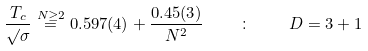<formula> <loc_0><loc_0><loc_500><loc_500>\frac { T _ { c } } { \surd \sigma } \stackrel { N \geq 2 } { = } 0 . 5 9 7 ( 4 ) + \frac { 0 . 4 5 ( 3 ) } { N ^ { 2 } } \quad \colon \quad D = 3 + 1</formula> 